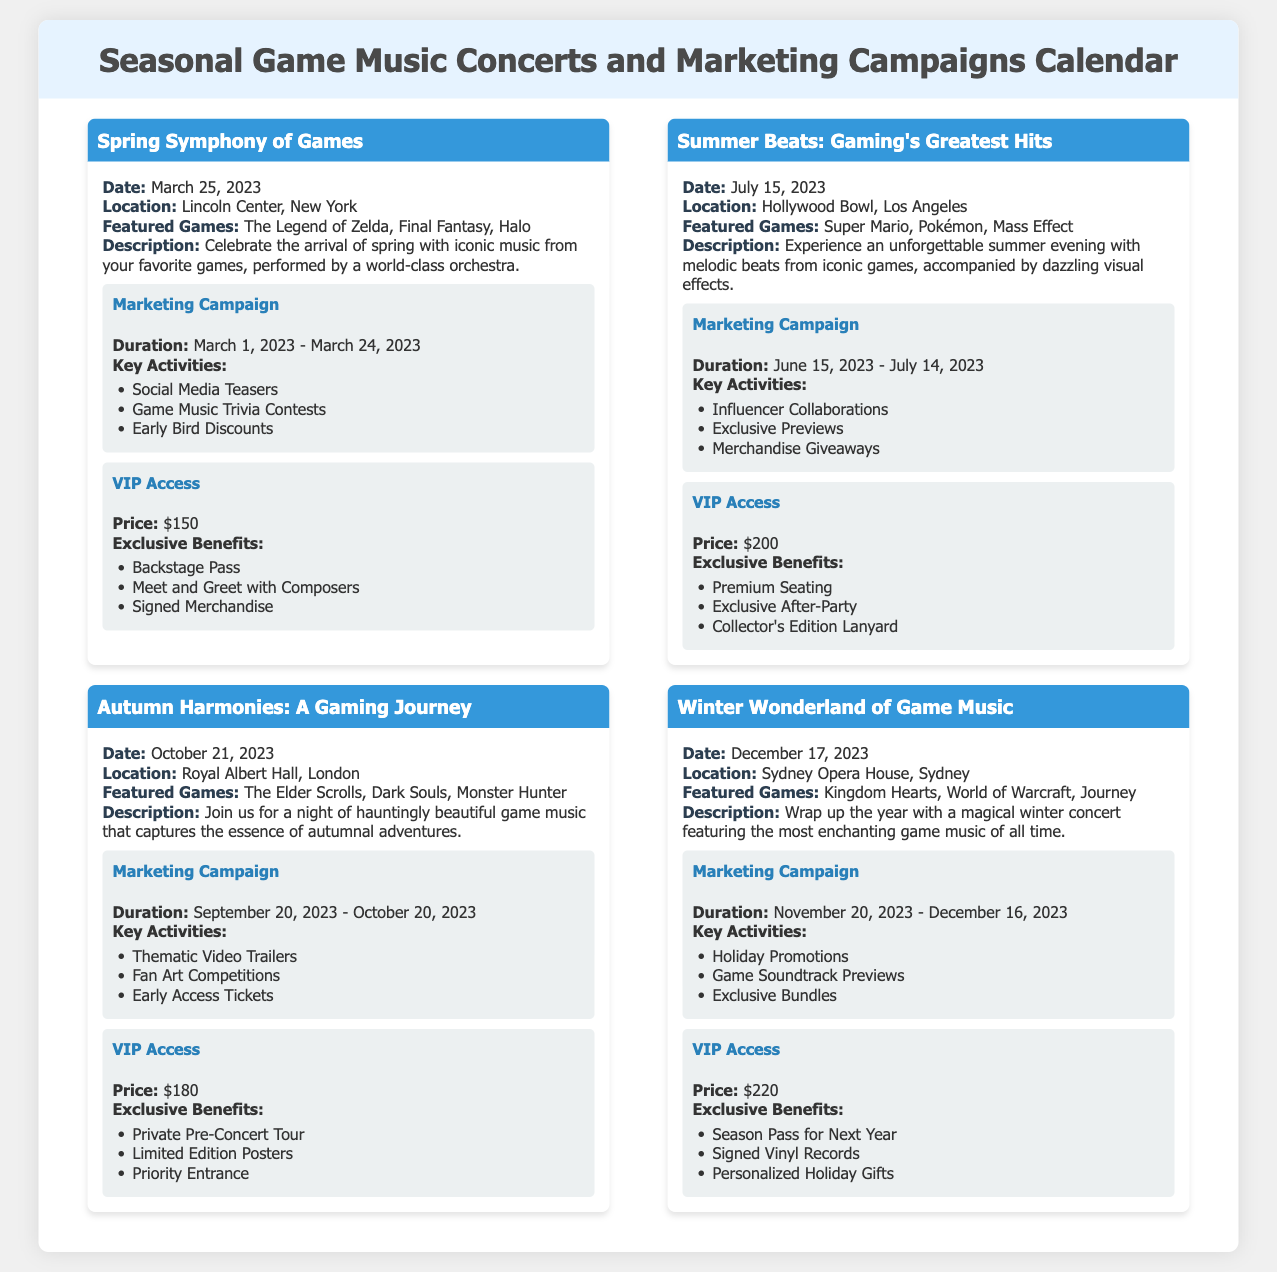What is the date of the Spring Symphony of Games? The date is stated under the event details section for Spring Symphony of Games, which is March 25, 2023.
Answer: March 25, 2023 Where is the Summer Beats concert held? The location is mentioned in the event details of Summer Beats, which is Hollywood Bowl, Los Angeles.
Answer: Hollywood Bowl, Los Angeles What is the price of VIP Access for the Winter Wonderland concert? The VIP Access price for Winter Wonderland is specified in that section as $220.
Answer: $220 Which featured game is associated with the Autumn Harmonies event? The featured games for Autumn Harmonies are listed, including The Elder Scrolls.
Answer: The Elder Scrolls What is the duration of the marketing campaign for Spring Symphony of Games? The marketing campaign duration is detailed, running from March 1, 2023 to March 24, 2023.
Answer: March 1, 2023 - March 24, 2023 How many events are scheduled in this calendar? The document lists four distinct events under the calendar section.
Answer: Four What are the exclusive benefits of the VIP Access for Summer Beats? The document specifies the exclusive benefits, including Premium Seating, Exclusive After-Party, and Collector's Edition Lanyard.
Answer: Premium Seating, Exclusive After-Party, Collector's Edition Lanyard When does the marketing campaign for Winter Wonderland start? The start date is noted in the marketing campaign section as November 20, 2023.
Answer: November 20, 2023 What is the common theme of all events in this calendar? The theme relates to music from popular video games, varying across seasons, as indicated in each event's description.
Answer: Music from popular video games 